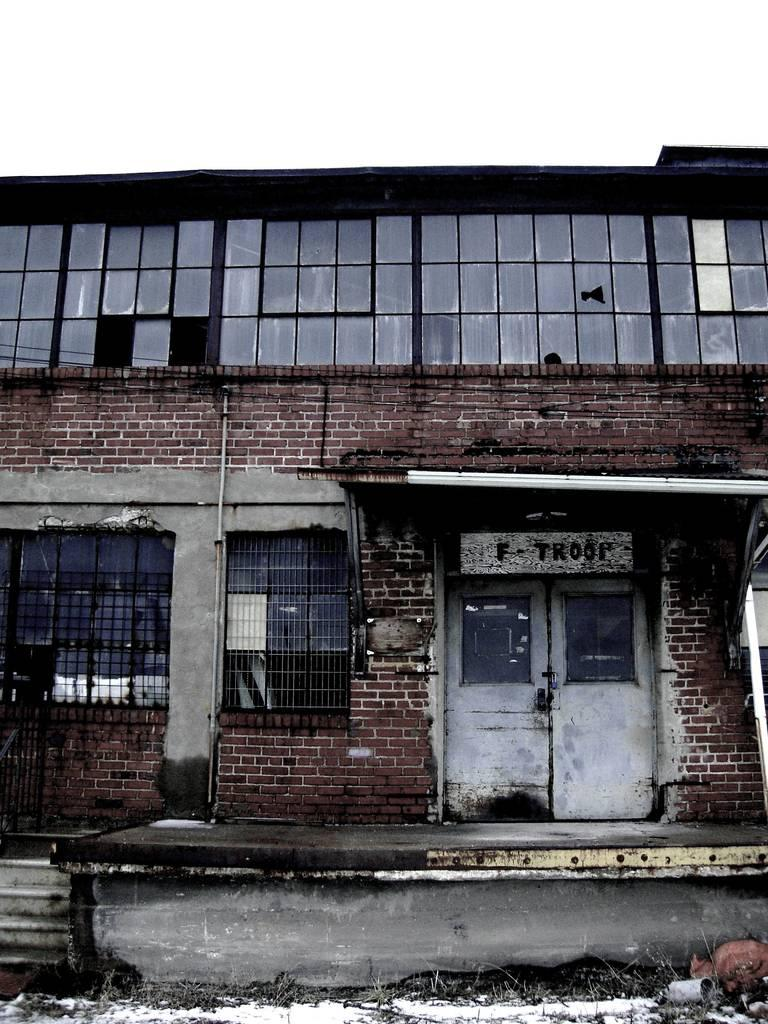What type of structure is in the image? There is a building in the image. What features can be seen on the building? The building has windows and doors. What type of material is used for the wall in the image? There is a brick wall in the image. What architectural feature is present in the image? There are stairs in the image. What type of rake is being used during the protest in the image? There is no rake or protest present in the image; it features a building with windows, doors, a brick wall, and stairs. 